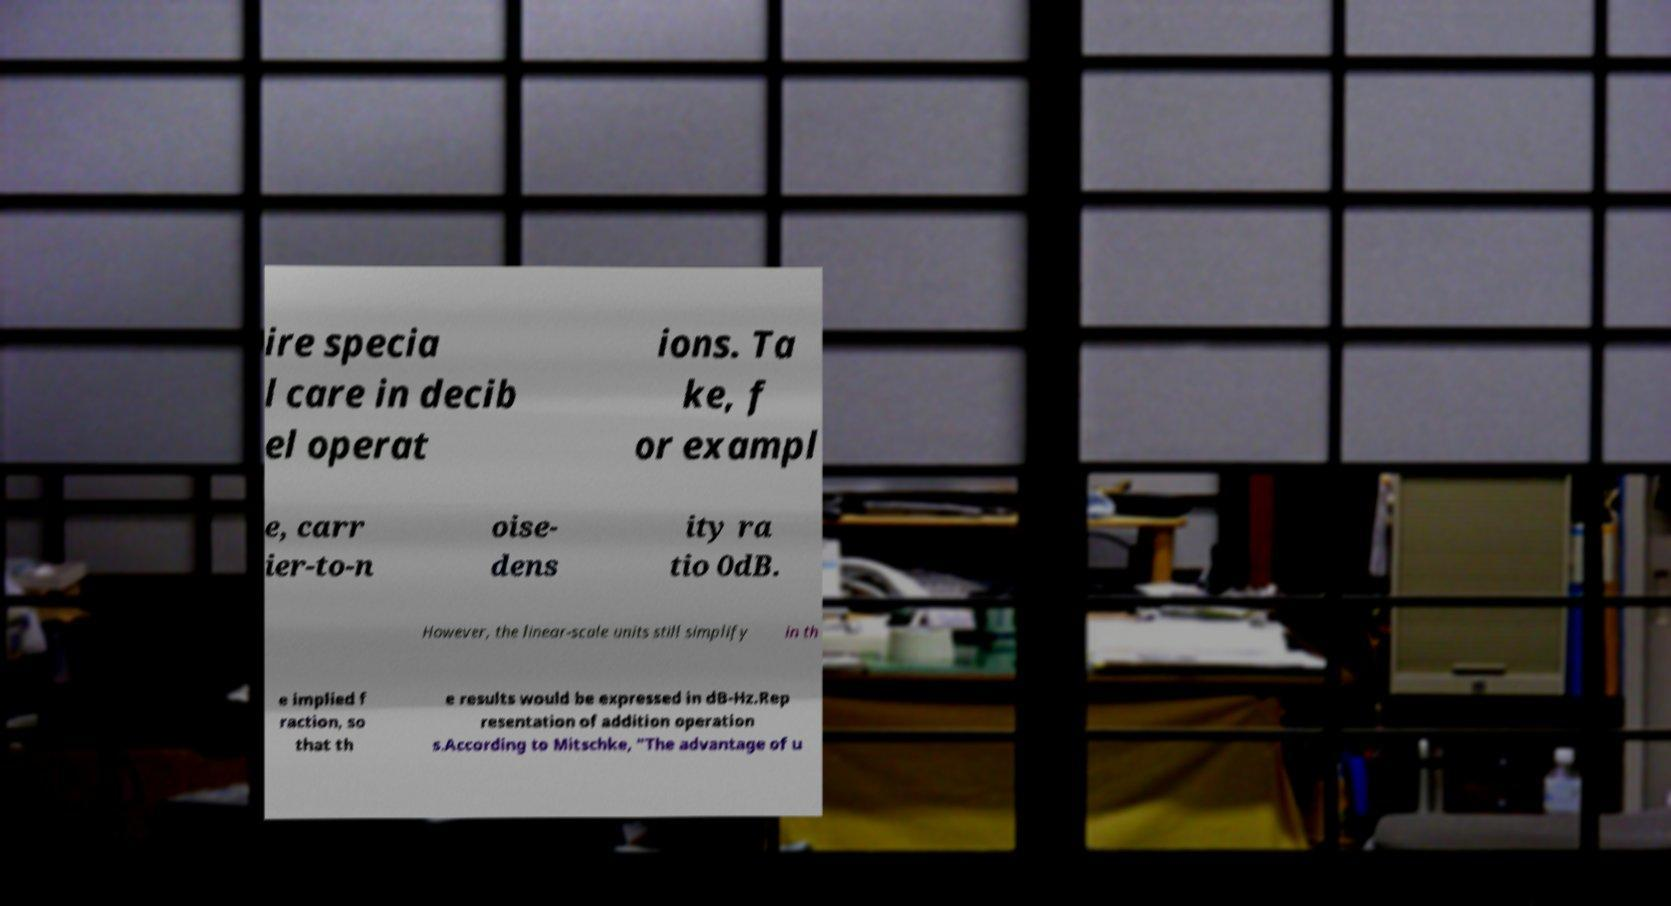Could you extract and type out the text from this image? ire specia l care in decib el operat ions. Ta ke, f or exampl e, carr ier-to-n oise- dens ity ra tio 0dB. However, the linear-scale units still simplify in th e implied f raction, so that th e results would be expressed in dB-Hz.Rep resentation of addition operation s.According to Mitschke, "The advantage of u 